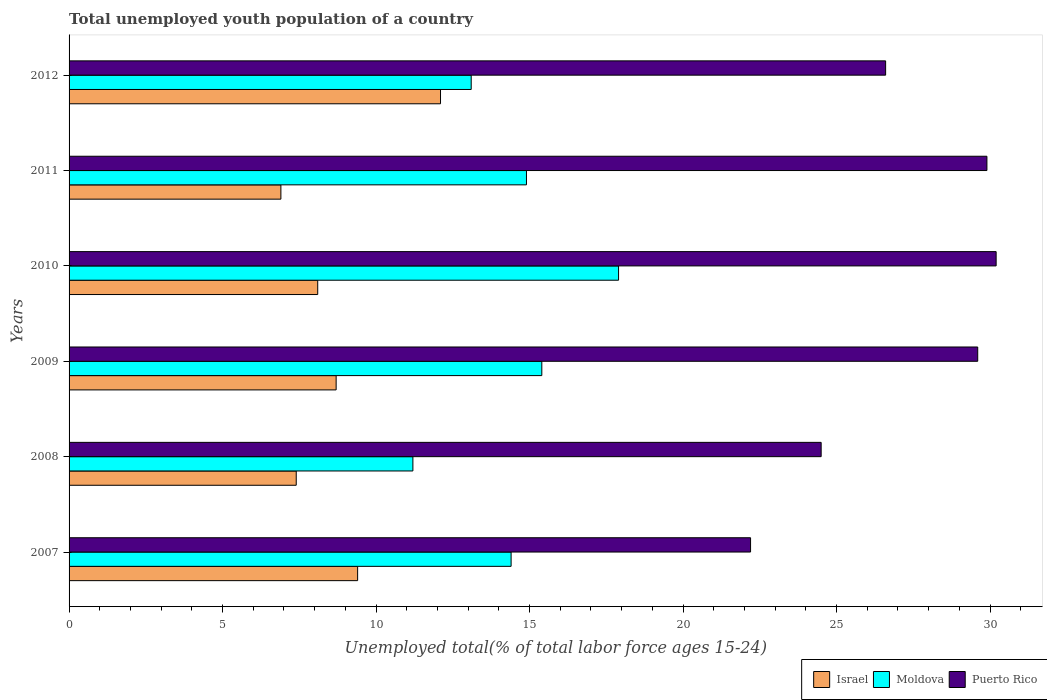How many groups of bars are there?
Your response must be concise. 6. Are the number of bars per tick equal to the number of legend labels?
Ensure brevity in your answer.  Yes. Are the number of bars on each tick of the Y-axis equal?
Your answer should be compact. Yes. How many bars are there on the 2nd tick from the top?
Give a very brief answer. 3. What is the label of the 6th group of bars from the top?
Make the answer very short. 2007. In how many cases, is the number of bars for a given year not equal to the number of legend labels?
Offer a very short reply. 0. What is the percentage of total unemployed youth population of a country in Moldova in 2010?
Provide a succinct answer. 17.9. Across all years, what is the maximum percentage of total unemployed youth population of a country in Puerto Rico?
Offer a very short reply. 30.2. Across all years, what is the minimum percentage of total unemployed youth population of a country in Puerto Rico?
Your answer should be compact. 22.2. In which year was the percentage of total unemployed youth population of a country in Puerto Rico maximum?
Give a very brief answer. 2010. In which year was the percentage of total unemployed youth population of a country in Moldova minimum?
Keep it short and to the point. 2008. What is the total percentage of total unemployed youth population of a country in Moldova in the graph?
Ensure brevity in your answer.  86.9. What is the difference between the percentage of total unemployed youth population of a country in Moldova in 2008 and that in 2010?
Keep it short and to the point. -6.7. What is the difference between the percentage of total unemployed youth population of a country in Puerto Rico in 2007 and the percentage of total unemployed youth population of a country in Moldova in 2012?
Provide a short and direct response. 9.1. What is the average percentage of total unemployed youth population of a country in Moldova per year?
Your response must be concise. 14.48. In the year 2008, what is the difference between the percentage of total unemployed youth population of a country in Moldova and percentage of total unemployed youth population of a country in Israel?
Your answer should be very brief. 3.8. In how many years, is the percentage of total unemployed youth population of a country in Israel greater than 2 %?
Your answer should be very brief. 6. What is the ratio of the percentage of total unemployed youth population of a country in Puerto Rico in 2009 to that in 2010?
Ensure brevity in your answer.  0.98. What is the difference between the highest and the second highest percentage of total unemployed youth population of a country in Moldova?
Give a very brief answer. 2.5. What is the difference between the highest and the lowest percentage of total unemployed youth population of a country in Moldova?
Make the answer very short. 6.7. What does the 1st bar from the bottom in 2011 represents?
Give a very brief answer. Israel. Are all the bars in the graph horizontal?
Provide a succinct answer. Yes. Are the values on the major ticks of X-axis written in scientific E-notation?
Give a very brief answer. No. Does the graph contain grids?
Provide a succinct answer. No. How many legend labels are there?
Provide a short and direct response. 3. How are the legend labels stacked?
Offer a very short reply. Horizontal. What is the title of the graph?
Keep it short and to the point. Total unemployed youth population of a country. Does "Chile" appear as one of the legend labels in the graph?
Provide a short and direct response. No. What is the label or title of the X-axis?
Your answer should be compact. Unemployed total(% of total labor force ages 15-24). What is the Unemployed total(% of total labor force ages 15-24) of Israel in 2007?
Provide a succinct answer. 9.4. What is the Unemployed total(% of total labor force ages 15-24) in Moldova in 2007?
Give a very brief answer. 14.4. What is the Unemployed total(% of total labor force ages 15-24) of Puerto Rico in 2007?
Your answer should be compact. 22.2. What is the Unemployed total(% of total labor force ages 15-24) of Israel in 2008?
Your answer should be very brief. 7.4. What is the Unemployed total(% of total labor force ages 15-24) of Moldova in 2008?
Make the answer very short. 11.2. What is the Unemployed total(% of total labor force ages 15-24) of Puerto Rico in 2008?
Ensure brevity in your answer.  24.5. What is the Unemployed total(% of total labor force ages 15-24) in Israel in 2009?
Keep it short and to the point. 8.7. What is the Unemployed total(% of total labor force ages 15-24) of Moldova in 2009?
Your answer should be compact. 15.4. What is the Unemployed total(% of total labor force ages 15-24) in Puerto Rico in 2009?
Keep it short and to the point. 29.6. What is the Unemployed total(% of total labor force ages 15-24) of Israel in 2010?
Offer a terse response. 8.1. What is the Unemployed total(% of total labor force ages 15-24) in Moldova in 2010?
Provide a short and direct response. 17.9. What is the Unemployed total(% of total labor force ages 15-24) in Puerto Rico in 2010?
Offer a very short reply. 30.2. What is the Unemployed total(% of total labor force ages 15-24) of Israel in 2011?
Keep it short and to the point. 6.9. What is the Unemployed total(% of total labor force ages 15-24) of Moldova in 2011?
Offer a terse response. 14.9. What is the Unemployed total(% of total labor force ages 15-24) of Puerto Rico in 2011?
Offer a terse response. 29.9. What is the Unemployed total(% of total labor force ages 15-24) in Israel in 2012?
Provide a succinct answer. 12.1. What is the Unemployed total(% of total labor force ages 15-24) in Moldova in 2012?
Offer a very short reply. 13.1. What is the Unemployed total(% of total labor force ages 15-24) in Puerto Rico in 2012?
Your response must be concise. 26.6. Across all years, what is the maximum Unemployed total(% of total labor force ages 15-24) in Israel?
Offer a terse response. 12.1. Across all years, what is the maximum Unemployed total(% of total labor force ages 15-24) in Moldova?
Your response must be concise. 17.9. Across all years, what is the maximum Unemployed total(% of total labor force ages 15-24) in Puerto Rico?
Ensure brevity in your answer.  30.2. Across all years, what is the minimum Unemployed total(% of total labor force ages 15-24) of Israel?
Make the answer very short. 6.9. Across all years, what is the minimum Unemployed total(% of total labor force ages 15-24) in Moldova?
Keep it short and to the point. 11.2. Across all years, what is the minimum Unemployed total(% of total labor force ages 15-24) in Puerto Rico?
Your answer should be very brief. 22.2. What is the total Unemployed total(% of total labor force ages 15-24) of Israel in the graph?
Your response must be concise. 52.6. What is the total Unemployed total(% of total labor force ages 15-24) in Moldova in the graph?
Keep it short and to the point. 86.9. What is the total Unemployed total(% of total labor force ages 15-24) of Puerto Rico in the graph?
Make the answer very short. 163. What is the difference between the Unemployed total(% of total labor force ages 15-24) in Israel in 2007 and that in 2008?
Give a very brief answer. 2. What is the difference between the Unemployed total(% of total labor force ages 15-24) in Moldova in 2007 and that in 2008?
Ensure brevity in your answer.  3.2. What is the difference between the Unemployed total(% of total labor force ages 15-24) in Puerto Rico in 2007 and that in 2008?
Provide a short and direct response. -2.3. What is the difference between the Unemployed total(% of total labor force ages 15-24) in Israel in 2007 and that in 2009?
Your response must be concise. 0.7. What is the difference between the Unemployed total(% of total labor force ages 15-24) of Puerto Rico in 2007 and that in 2009?
Your response must be concise. -7.4. What is the difference between the Unemployed total(% of total labor force ages 15-24) of Israel in 2007 and that in 2010?
Provide a short and direct response. 1.3. What is the difference between the Unemployed total(% of total labor force ages 15-24) of Moldova in 2007 and that in 2010?
Give a very brief answer. -3.5. What is the difference between the Unemployed total(% of total labor force ages 15-24) in Puerto Rico in 2007 and that in 2011?
Provide a succinct answer. -7.7. What is the difference between the Unemployed total(% of total labor force ages 15-24) in Puerto Rico in 2007 and that in 2012?
Your response must be concise. -4.4. What is the difference between the Unemployed total(% of total labor force ages 15-24) in Israel in 2008 and that in 2009?
Make the answer very short. -1.3. What is the difference between the Unemployed total(% of total labor force ages 15-24) in Israel in 2008 and that in 2010?
Make the answer very short. -0.7. What is the difference between the Unemployed total(% of total labor force ages 15-24) of Moldova in 2008 and that in 2010?
Your answer should be compact. -6.7. What is the difference between the Unemployed total(% of total labor force ages 15-24) of Puerto Rico in 2008 and that in 2010?
Offer a very short reply. -5.7. What is the difference between the Unemployed total(% of total labor force ages 15-24) of Israel in 2008 and that in 2011?
Your answer should be compact. 0.5. What is the difference between the Unemployed total(% of total labor force ages 15-24) in Moldova in 2008 and that in 2011?
Provide a short and direct response. -3.7. What is the difference between the Unemployed total(% of total labor force ages 15-24) in Puerto Rico in 2008 and that in 2011?
Offer a very short reply. -5.4. What is the difference between the Unemployed total(% of total labor force ages 15-24) in Israel in 2009 and that in 2010?
Your response must be concise. 0.6. What is the difference between the Unemployed total(% of total labor force ages 15-24) in Israel in 2010 and that in 2011?
Offer a very short reply. 1.2. What is the difference between the Unemployed total(% of total labor force ages 15-24) in Moldova in 2010 and that in 2012?
Ensure brevity in your answer.  4.8. What is the difference between the Unemployed total(% of total labor force ages 15-24) in Puerto Rico in 2010 and that in 2012?
Offer a very short reply. 3.6. What is the difference between the Unemployed total(% of total labor force ages 15-24) in Moldova in 2011 and that in 2012?
Make the answer very short. 1.8. What is the difference between the Unemployed total(% of total labor force ages 15-24) in Puerto Rico in 2011 and that in 2012?
Offer a very short reply. 3.3. What is the difference between the Unemployed total(% of total labor force ages 15-24) in Israel in 2007 and the Unemployed total(% of total labor force ages 15-24) in Moldova in 2008?
Keep it short and to the point. -1.8. What is the difference between the Unemployed total(% of total labor force ages 15-24) in Israel in 2007 and the Unemployed total(% of total labor force ages 15-24) in Puerto Rico in 2008?
Your response must be concise. -15.1. What is the difference between the Unemployed total(% of total labor force ages 15-24) in Moldova in 2007 and the Unemployed total(% of total labor force ages 15-24) in Puerto Rico in 2008?
Offer a very short reply. -10.1. What is the difference between the Unemployed total(% of total labor force ages 15-24) in Israel in 2007 and the Unemployed total(% of total labor force ages 15-24) in Moldova in 2009?
Provide a short and direct response. -6. What is the difference between the Unemployed total(% of total labor force ages 15-24) of Israel in 2007 and the Unemployed total(% of total labor force ages 15-24) of Puerto Rico in 2009?
Ensure brevity in your answer.  -20.2. What is the difference between the Unemployed total(% of total labor force ages 15-24) of Moldova in 2007 and the Unemployed total(% of total labor force ages 15-24) of Puerto Rico in 2009?
Provide a succinct answer. -15.2. What is the difference between the Unemployed total(% of total labor force ages 15-24) in Israel in 2007 and the Unemployed total(% of total labor force ages 15-24) in Puerto Rico in 2010?
Your answer should be very brief. -20.8. What is the difference between the Unemployed total(% of total labor force ages 15-24) of Moldova in 2007 and the Unemployed total(% of total labor force ages 15-24) of Puerto Rico in 2010?
Give a very brief answer. -15.8. What is the difference between the Unemployed total(% of total labor force ages 15-24) in Israel in 2007 and the Unemployed total(% of total labor force ages 15-24) in Moldova in 2011?
Offer a very short reply. -5.5. What is the difference between the Unemployed total(% of total labor force ages 15-24) of Israel in 2007 and the Unemployed total(% of total labor force ages 15-24) of Puerto Rico in 2011?
Your answer should be very brief. -20.5. What is the difference between the Unemployed total(% of total labor force ages 15-24) of Moldova in 2007 and the Unemployed total(% of total labor force ages 15-24) of Puerto Rico in 2011?
Your response must be concise. -15.5. What is the difference between the Unemployed total(% of total labor force ages 15-24) in Israel in 2007 and the Unemployed total(% of total labor force ages 15-24) in Puerto Rico in 2012?
Keep it short and to the point. -17.2. What is the difference between the Unemployed total(% of total labor force ages 15-24) of Israel in 2008 and the Unemployed total(% of total labor force ages 15-24) of Puerto Rico in 2009?
Provide a short and direct response. -22.2. What is the difference between the Unemployed total(% of total labor force ages 15-24) in Moldova in 2008 and the Unemployed total(% of total labor force ages 15-24) in Puerto Rico in 2009?
Ensure brevity in your answer.  -18.4. What is the difference between the Unemployed total(% of total labor force ages 15-24) of Israel in 2008 and the Unemployed total(% of total labor force ages 15-24) of Moldova in 2010?
Your answer should be very brief. -10.5. What is the difference between the Unemployed total(% of total labor force ages 15-24) in Israel in 2008 and the Unemployed total(% of total labor force ages 15-24) in Puerto Rico in 2010?
Provide a short and direct response. -22.8. What is the difference between the Unemployed total(% of total labor force ages 15-24) in Israel in 2008 and the Unemployed total(% of total labor force ages 15-24) in Puerto Rico in 2011?
Provide a short and direct response. -22.5. What is the difference between the Unemployed total(% of total labor force ages 15-24) in Moldova in 2008 and the Unemployed total(% of total labor force ages 15-24) in Puerto Rico in 2011?
Offer a very short reply. -18.7. What is the difference between the Unemployed total(% of total labor force ages 15-24) in Israel in 2008 and the Unemployed total(% of total labor force ages 15-24) in Puerto Rico in 2012?
Give a very brief answer. -19.2. What is the difference between the Unemployed total(% of total labor force ages 15-24) of Moldova in 2008 and the Unemployed total(% of total labor force ages 15-24) of Puerto Rico in 2012?
Your answer should be very brief. -15.4. What is the difference between the Unemployed total(% of total labor force ages 15-24) of Israel in 2009 and the Unemployed total(% of total labor force ages 15-24) of Moldova in 2010?
Provide a short and direct response. -9.2. What is the difference between the Unemployed total(% of total labor force ages 15-24) in Israel in 2009 and the Unemployed total(% of total labor force ages 15-24) in Puerto Rico in 2010?
Provide a short and direct response. -21.5. What is the difference between the Unemployed total(% of total labor force ages 15-24) in Moldova in 2009 and the Unemployed total(% of total labor force ages 15-24) in Puerto Rico in 2010?
Offer a terse response. -14.8. What is the difference between the Unemployed total(% of total labor force ages 15-24) of Israel in 2009 and the Unemployed total(% of total labor force ages 15-24) of Puerto Rico in 2011?
Offer a terse response. -21.2. What is the difference between the Unemployed total(% of total labor force ages 15-24) of Moldova in 2009 and the Unemployed total(% of total labor force ages 15-24) of Puerto Rico in 2011?
Offer a very short reply. -14.5. What is the difference between the Unemployed total(% of total labor force ages 15-24) of Israel in 2009 and the Unemployed total(% of total labor force ages 15-24) of Puerto Rico in 2012?
Offer a very short reply. -17.9. What is the difference between the Unemployed total(% of total labor force ages 15-24) in Israel in 2010 and the Unemployed total(% of total labor force ages 15-24) in Moldova in 2011?
Your response must be concise. -6.8. What is the difference between the Unemployed total(% of total labor force ages 15-24) in Israel in 2010 and the Unemployed total(% of total labor force ages 15-24) in Puerto Rico in 2011?
Keep it short and to the point. -21.8. What is the difference between the Unemployed total(% of total labor force ages 15-24) of Moldova in 2010 and the Unemployed total(% of total labor force ages 15-24) of Puerto Rico in 2011?
Offer a very short reply. -12. What is the difference between the Unemployed total(% of total labor force ages 15-24) in Israel in 2010 and the Unemployed total(% of total labor force ages 15-24) in Moldova in 2012?
Provide a short and direct response. -5. What is the difference between the Unemployed total(% of total labor force ages 15-24) in Israel in 2010 and the Unemployed total(% of total labor force ages 15-24) in Puerto Rico in 2012?
Your response must be concise. -18.5. What is the difference between the Unemployed total(% of total labor force ages 15-24) in Israel in 2011 and the Unemployed total(% of total labor force ages 15-24) in Puerto Rico in 2012?
Keep it short and to the point. -19.7. What is the difference between the Unemployed total(% of total labor force ages 15-24) in Moldova in 2011 and the Unemployed total(% of total labor force ages 15-24) in Puerto Rico in 2012?
Provide a short and direct response. -11.7. What is the average Unemployed total(% of total labor force ages 15-24) in Israel per year?
Your answer should be compact. 8.77. What is the average Unemployed total(% of total labor force ages 15-24) in Moldova per year?
Give a very brief answer. 14.48. What is the average Unemployed total(% of total labor force ages 15-24) in Puerto Rico per year?
Your answer should be compact. 27.17. In the year 2007, what is the difference between the Unemployed total(% of total labor force ages 15-24) in Israel and Unemployed total(% of total labor force ages 15-24) in Moldova?
Your answer should be compact. -5. In the year 2007, what is the difference between the Unemployed total(% of total labor force ages 15-24) in Israel and Unemployed total(% of total labor force ages 15-24) in Puerto Rico?
Keep it short and to the point. -12.8. In the year 2007, what is the difference between the Unemployed total(% of total labor force ages 15-24) in Moldova and Unemployed total(% of total labor force ages 15-24) in Puerto Rico?
Your answer should be compact. -7.8. In the year 2008, what is the difference between the Unemployed total(% of total labor force ages 15-24) in Israel and Unemployed total(% of total labor force ages 15-24) in Puerto Rico?
Give a very brief answer. -17.1. In the year 2009, what is the difference between the Unemployed total(% of total labor force ages 15-24) in Israel and Unemployed total(% of total labor force ages 15-24) in Moldova?
Offer a terse response. -6.7. In the year 2009, what is the difference between the Unemployed total(% of total labor force ages 15-24) in Israel and Unemployed total(% of total labor force ages 15-24) in Puerto Rico?
Your answer should be compact. -20.9. In the year 2010, what is the difference between the Unemployed total(% of total labor force ages 15-24) in Israel and Unemployed total(% of total labor force ages 15-24) in Puerto Rico?
Ensure brevity in your answer.  -22.1. In the year 2011, what is the difference between the Unemployed total(% of total labor force ages 15-24) in Israel and Unemployed total(% of total labor force ages 15-24) in Moldova?
Your response must be concise. -8. In the year 2011, what is the difference between the Unemployed total(% of total labor force ages 15-24) of Israel and Unemployed total(% of total labor force ages 15-24) of Puerto Rico?
Make the answer very short. -23. What is the ratio of the Unemployed total(% of total labor force ages 15-24) in Israel in 2007 to that in 2008?
Your answer should be compact. 1.27. What is the ratio of the Unemployed total(% of total labor force ages 15-24) in Moldova in 2007 to that in 2008?
Provide a succinct answer. 1.29. What is the ratio of the Unemployed total(% of total labor force ages 15-24) of Puerto Rico in 2007 to that in 2008?
Provide a succinct answer. 0.91. What is the ratio of the Unemployed total(% of total labor force ages 15-24) in Israel in 2007 to that in 2009?
Make the answer very short. 1.08. What is the ratio of the Unemployed total(% of total labor force ages 15-24) of Moldova in 2007 to that in 2009?
Your answer should be compact. 0.94. What is the ratio of the Unemployed total(% of total labor force ages 15-24) in Puerto Rico in 2007 to that in 2009?
Ensure brevity in your answer.  0.75. What is the ratio of the Unemployed total(% of total labor force ages 15-24) in Israel in 2007 to that in 2010?
Your response must be concise. 1.16. What is the ratio of the Unemployed total(% of total labor force ages 15-24) in Moldova in 2007 to that in 2010?
Give a very brief answer. 0.8. What is the ratio of the Unemployed total(% of total labor force ages 15-24) of Puerto Rico in 2007 to that in 2010?
Your answer should be very brief. 0.74. What is the ratio of the Unemployed total(% of total labor force ages 15-24) of Israel in 2007 to that in 2011?
Keep it short and to the point. 1.36. What is the ratio of the Unemployed total(% of total labor force ages 15-24) in Moldova in 2007 to that in 2011?
Ensure brevity in your answer.  0.97. What is the ratio of the Unemployed total(% of total labor force ages 15-24) in Puerto Rico in 2007 to that in 2011?
Ensure brevity in your answer.  0.74. What is the ratio of the Unemployed total(% of total labor force ages 15-24) in Israel in 2007 to that in 2012?
Provide a short and direct response. 0.78. What is the ratio of the Unemployed total(% of total labor force ages 15-24) of Moldova in 2007 to that in 2012?
Provide a succinct answer. 1.1. What is the ratio of the Unemployed total(% of total labor force ages 15-24) in Puerto Rico in 2007 to that in 2012?
Keep it short and to the point. 0.83. What is the ratio of the Unemployed total(% of total labor force ages 15-24) in Israel in 2008 to that in 2009?
Keep it short and to the point. 0.85. What is the ratio of the Unemployed total(% of total labor force ages 15-24) of Moldova in 2008 to that in 2009?
Offer a terse response. 0.73. What is the ratio of the Unemployed total(% of total labor force ages 15-24) in Puerto Rico in 2008 to that in 2009?
Offer a very short reply. 0.83. What is the ratio of the Unemployed total(% of total labor force ages 15-24) of Israel in 2008 to that in 2010?
Make the answer very short. 0.91. What is the ratio of the Unemployed total(% of total labor force ages 15-24) of Moldova in 2008 to that in 2010?
Your response must be concise. 0.63. What is the ratio of the Unemployed total(% of total labor force ages 15-24) in Puerto Rico in 2008 to that in 2010?
Offer a very short reply. 0.81. What is the ratio of the Unemployed total(% of total labor force ages 15-24) of Israel in 2008 to that in 2011?
Keep it short and to the point. 1.07. What is the ratio of the Unemployed total(% of total labor force ages 15-24) of Moldova in 2008 to that in 2011?
Make the answer very short. 0.75. What is the ratio of the Unemployed total(% of total labor force ages 15-24) of Puerto Rico in 2008 to that in 2011?
Your answer should be compact. 0.82. What is the ratio of the Unemployed total(% of total labor force ages 15-24) in Israel in 2008 to that in 2012?
Give a very brief answer. 0.61. What is the ratio of the Unemployed total(% of total labor force ages 15-24) in Moldova in 2008 to that in 2012?
Make the answer very short. 0.85. What is the ratio of the Unemployed total(% of total labor force ages 15-24) of Puerto Rico in 2008 to that in 2012?
Ensure brevity in your answer.  0.92. What is the ratio of the Unemployed total(% of total labor force ages 15-24) in Israel in 2009 to that in 2010?
Provide a short and direct response. 1.07. What is the ratio of the Unemployed total(% of total labor force ages 15-24) of Moldova in 2009 to that in 2010?
Ensure brevity in your answer.  0.86. What is the ratio of the Unemployed total(% of total labor force ages 15-24) in Puerto Rico in 2009 to that in 2010?
Your response must be concise. 0.98. What is the ratio of the Unemployed total(% of total labor force ages 15-24) in Israel in 2009 to that in 2011?
Provide a succinct answer. 1.26. What is the ratio of the Unemployed total(% of total labor force ages 15-24) of Moldova in 2009 to that in 2011?
Give a very brief answer. 1.03. What is the ratio of the Unemployed total(% of total labor force ages 15-24) of Israel in 2009 to that in 2012?
Offer a very short reply. 0.72. What is the ratio of the Unemployed total(% of total labor force ages 15-24) of Moldova in 2009 to that in 2012?
Offer a very short reply. 1.18. What is the ratio of the Unemployed total(% of total labor force ages 15-24) in Puerto Rico in 2009 to that in 2012?
Provide a succinct answer. 1.11. What is the ratio of the Unemployed total(% of total labor force ages 15-24) of Israel in 2010 to that in 2011?
Your response must be concise. 1.17. What is the ratio of the Unemployed total(% of total labor force ages 15-24) of Moldova in 2010 to that in 2011?
Your answer should be very brief. 1.2. What is the ratio of the Unemployed total(% of total labor force ages 15-24) in Puerto Rico in 2010 to that in 2011?
Your answer should be very brief. 1.01. What is the ratio of the Unemployed total(% of total labor force ages 15-24) in Israel in 2010 to that in 2012?
Keep it short and to the point. 0.67. What is the ratio of the Unemployed total(% of total labor force ages 15-24) in Moldova in 2010 to that in 2012?
Provide a short and direct response. 1.37. What is the ratio of the Unemployed total(% of total labor force ages 15-24) in Puerto Rico in 2010 to that in 2012?
Ensure brevity in your answer.  1.14. What is the ratio of the Unemployed total(% of total labor force ages 15-24) in Israel in 2011 to that in 2012?
Your answer should be compact. 0.57. What is the ratio of the Unemployed total(% of total labor force ages 15-24) in Moldova in 2011 to that in 2012?
Your response must be concise. 1.14. What is the ratio of the Unemployed total(% of total labor force ages 15-24) of Puerto Rico in 2011 to that in 2012?
Your answer should be compact. 1.12. What is the difference between the highest and the second highest Unemployed total(% of total labor force ages 15-24) in Israel?
Provide a short and direct response. 2.7. What is the difference between the highest and the second highest Unemployed total(% of total labor force ages 15-24) of Moldova?
Your answer should be very brief. 2.5. What is the difference between the highest and the second highest Unemployed total(% of total labor force ages 15-24) of Puerto Rico?
Make the answer very short. 0.3. What is the difference between the highest and the lowest Unemployed total(% of total labor force ages 15-24) of Israel?
Your answer should be very brief. 5.2. What is the difference between the highest and the lowest Unemployed total(% of total labor force ages 15-24) of Puerto Rico?
Provide a succinct answer. 8. 